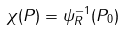<formula> <loc_0><loc_0><loc_500><loc_500>\chi ( P ) = \psi _ { R } ^ { - 1 } ( P _ { 0 } )</formula> 